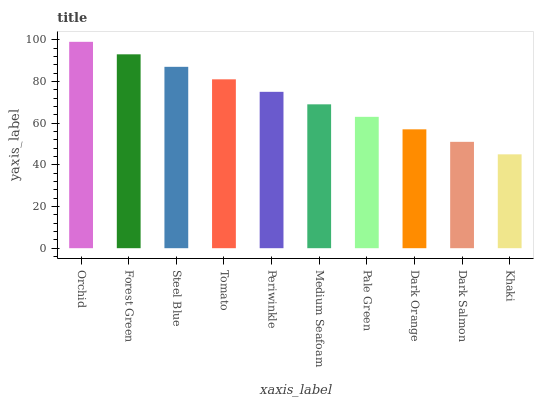Is Khaki the minimum?
Answer yes or no. Yes. Is Orchid the maximum?
Answer yes or no. Yes. Is Forest Green the minimum?
Answer yes or no. No. Is Forest Green the maximum?
Answer yes or no. No. Is Orchid greater than Forest Green?
Answer yes or no. Yes. Is Forest Green less than Orchid?
Answer yes or no. Yes. Is Forest Green greater than Orchid?
Answer yes or no. No. Is Orchid less than Forest Green?
Answer yes or no. No. Is Periwinkle the high median?
Answer yes or no. Yes. Is Medium Seafoam the low median?
Answer yes or no. Yes. Is Steel Blue the high median?
Answer yes or no. No. Is Khaki the low median?
Answer yes or no. No. 